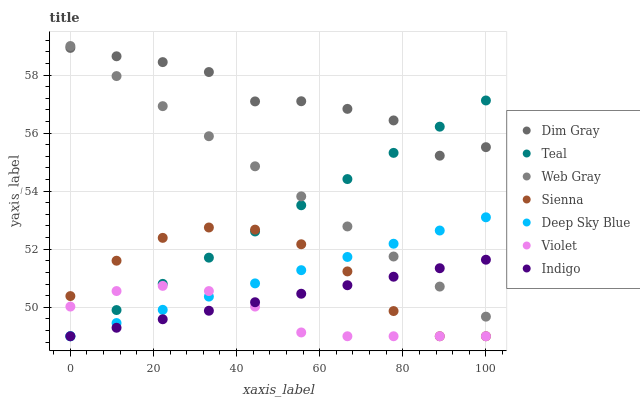Does Violet have the minimum area under the curve?
Answer yes or no. Yes. Does Dim Gray have the maximum area under the curve?
Answer yes or no. Yes. Does Indigo have the minimum area under the curve?
Answer yes or no. No. Does Indigo have the maximum area under the curve?
Answer yes or no. No. Is Indigo the smoothest?
Answer yes or no. Yes. Is Dim Gray the roughest?
Answer yes or no. Yes. Is Teal the smoothest?
Answer yes or no. No. Is Teal the roughest?
Answer yes or no. No. Does Indigo have the lowest value?
Answer yes or no. Yes. Does Web Gray have the lowest value?
Answer yes or no. No. Does Web Gray have the highest value?
Answer yes or no. Yes. Does Indigo have the highest value?
Answer yes or no. No. Is Sienna less than Web Gray?
Answer yes or no. Yes. Is Dim Gray greater than Indigo?
Answer yes or no. Yes. Does Deep Sky Blue intersect Indigo?
Answer yes or no. Yes. Is Deep Sky Blue less than Indigo?
Answer yes or no. No. Is Deep Sky Blue greater than Indigo?
Answer yes or no. No. Does Sienna intersect Web Gray?
Answer yes or no. No. 